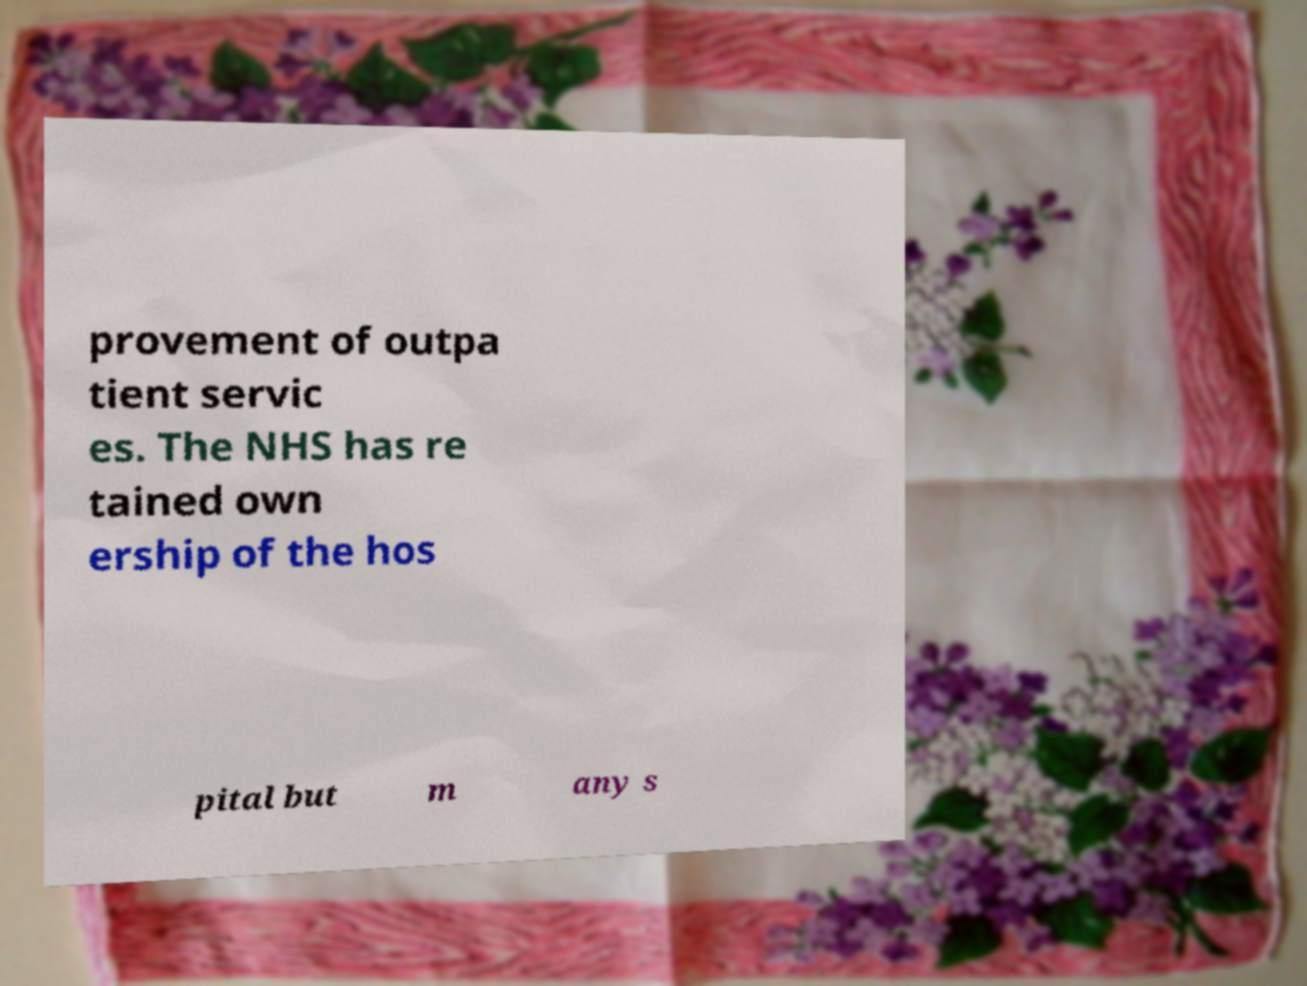Could you assist in decoding the text presented in this image and type it out clearly? provement of outpa tient servic es. The NHS has re tained own ership of the hos pital but m any s 